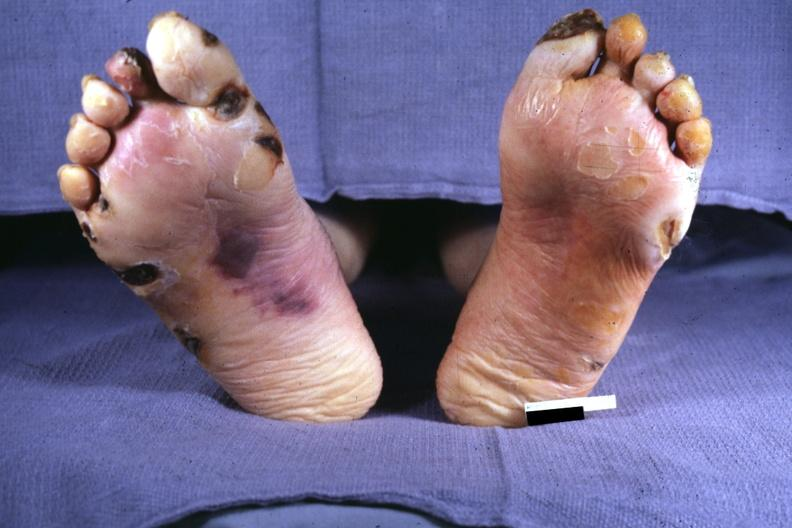does heart show typical gangrene?
Answer the question using a single word or phrase. No 